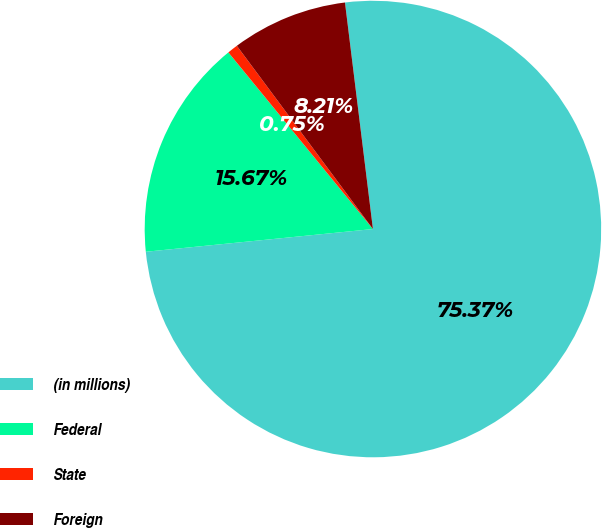<chart> <loc_0><loc_0><loc_500><loc_500><pie_chart><fcel>(in millions)<fcel>Federal<fcel>State<fcel>Foreign<nl><fcel>75.36%<fcel>15.67%<fcel>0.75%<fcel>8.21%<nl></chart> 